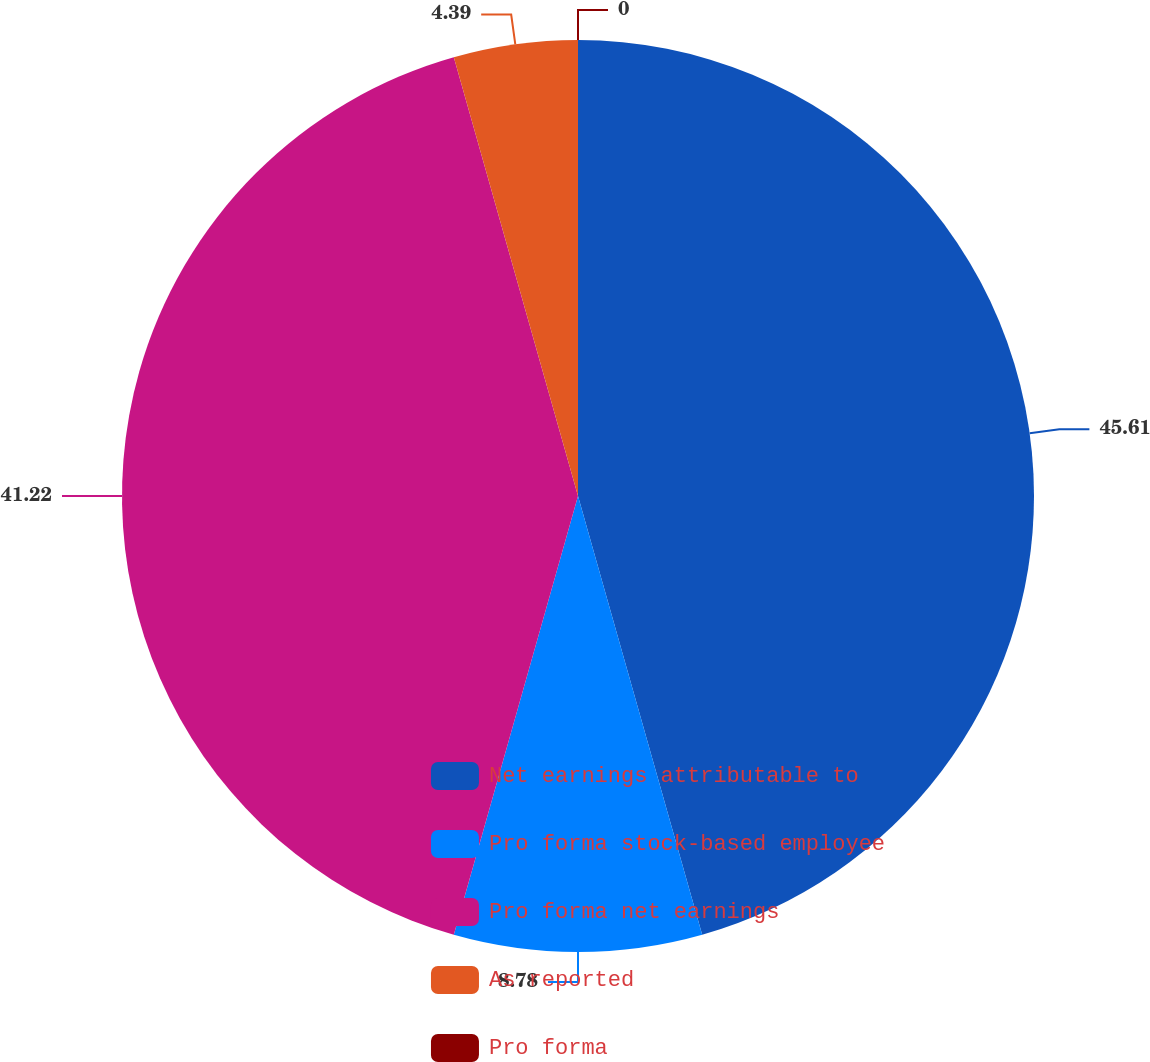Convert chart. <chart><loc_0><loc_0><loc_500><loc_500><pie_chart><fcel>Net earnings attributable to<fcel>Pro forma stock-based employee<fcel>Pro forma net earnings<fcel>As reported<fcel>Pro forma<nl><fcel>45.61%<fcel>8.78%<fcel>41.22%<fcel>4.39%<fcel>0.0%<nl></chart> 